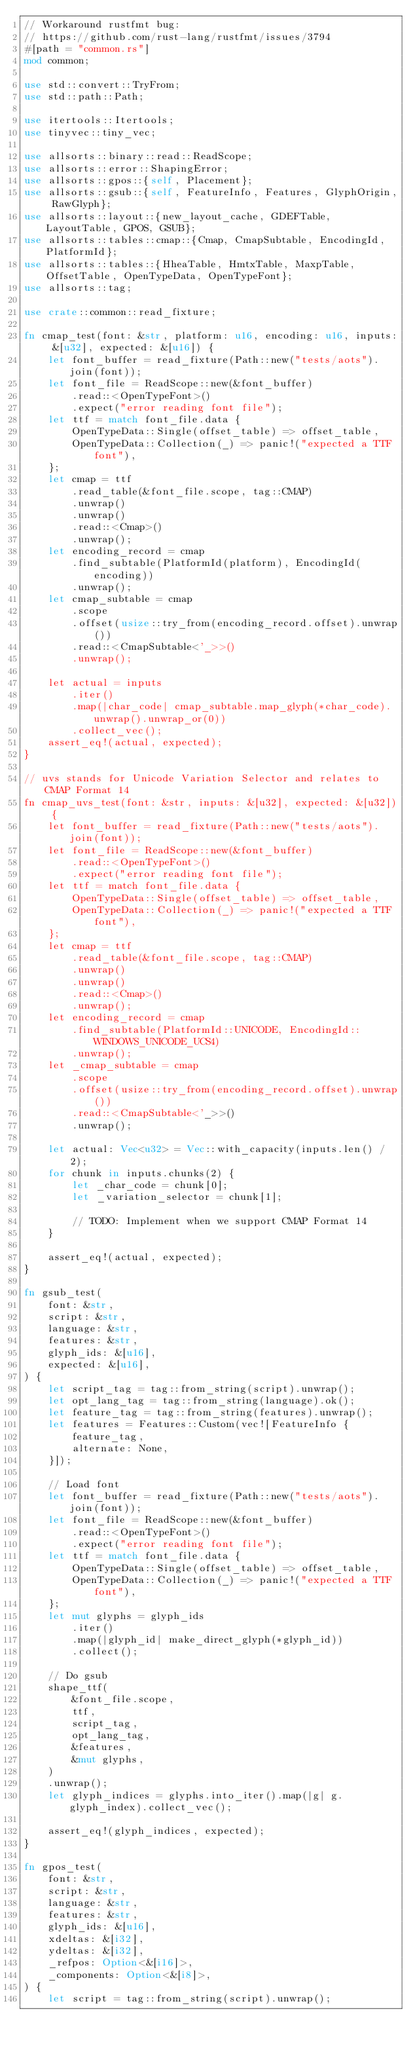<code> <loc_0><loc_0><loc_500><loc_500><_Rust_>// Workaround rustfmt bug:
// https://github.com/rust-lang/rustfmt/issues/3794
#[path = "common.rs"]
mod common;

use std::convert::TryFrom;
use std::path::Path;

use itertools::Itertools;
use tinyvec::tiny_vec;

use allsorts::binary::read::ReadScope;
use allsorts::error::ShapingError;
use allsorts::gpos::{self, Placement};
use allsorts::gsub::{self, FeatureInfo, Features, GlyphOrigin, RawGlyph};
use allsorts::layout::{new_layout_cache, GDEFTable, LayoutTable, GPOS, GSUB};
use allsorts::tables::cmap::{Cmap, CmapSubtable, EncodingId, PlatformId};
use allsorts::tables::{HheaTable, HmtxTable, MaxpTable, OffsetTable, OpenTypeData, OpenTypeFont};
use allsorts::tag;

use crate::common::read_fixture;

fn cmap_test(font: &str, platform: u16, encoding: u16, inputs: &[u32], expected: &[u16]) {
    let font_buffer = read_fixture(Path::new("tests/aots").join(font));
    let font_file = ReadScope::new(&font_buffer)
        .read::<OpenTypeFont>()
        .expect("error reading font file");
    let ttf = match font_file.data {
        OpenTypeData::Single(offset_table) => offset_table,
        OpenTypeData::Collection(_) => panic!("expected a TTF font"),
    };
    let cmap = ttf
        .read_table(&font_file.scope, tag::CMAP)
        .unwrap()
        .unwrap()
        .read::<Cmap>()
        .unwrap();
    let encoding_record = cmap
        .find_subtable(PlatformId(platform), EncodingId(encoding))
        .unwrap();
    let cmap_subtable = cmap
        .scope
        .offset(usize::try_from(encoding_record.offset).unwrap())
        .read::<CmapSubtable<'_>>()
        .unwrap();

    let actual = inputs
        .iter()
        .map(|char_code| cmap_subtable.map_glyph(*char_code).unwrap().unwrap_or(0))
        .collect_vec();
    assert_eq!(actual, expected);
}

// uvs stands for Unicode Variation Selector and relates to CMAP Format 14
fn cmap_uvs_test(font: &str, inputs: &[u32], expected: &[u32]) {
    let font_buffer = read_fixture(Path::new("tests/aots").join(font));
    let font_file = ReadScope::new(&font_buffer)
        .read::<OpenTypeFont>()
        .expect("error reading font file");
    let ttf = match font_file.data {
        OpenTypeData::Single(offset_table) => offset_table,
        OpenTypeData::Collection(_) => panic!("expected a TTF font"),
    };
    let cmap = ttf
        .read_table(&font_file.scope, tag::CMAP)
        .unwrap()
        .unwrap()
        .read::<Cmap>()
        .unwrap();
    let encoding_record = cmap
        .find_subtable(PlatformId::UNICODE, EncodingId::WINDOWS_UNICODE_UCS4)
        .unwrap();
    let _cmap_subtable = cmap
        .scope
        .offset(usize::try_from(encoding_record.offset).unwrap())
        .read::<CmapSubtable<'_>>()
        .unwrap();

    let actual: Vec<u32> = Vec::with_capacity(inputs.len() / 2);
    for chunk in inputs.chunks(2) {
        let _char_code = chunk[0];
        let _variation_selector = chunk[1];

        // TODO: Implement when we support CMAP Format 14
    }

    assert_eq!(actual, expected);
}

fn gsub_test(
    font: &str,
    script: &str,
    language: &str,
    features: &str,
    glyph_ids: &[u16],
    expected: &[u16],
) {
    let script_tag = tag::from_string(script).unwrap();
    let opt_lang_tag = tag::from_string(language).ok();
    let feature_tag = tag::from_string(features).unwrap();
    let features = Features::Custom(vec![FeatureInfo {
        feature_tag,
        alternate: None,
    }]);

    // Load font
    let font_buffer = read_fixture(Path::new("tests/aots").join(font));
    let font_file = ReadScope::new(&font_buffer)
        .read::<OpenTypeFont>()
        .expect("error reading font file");
    let ttf = match font_file.data {
        OpenTypeData::Single(offset_table) => offset_table,
        OpenTypeData::Collection(_) => panic!("expected a TTF font"),
    };
    let mut glyphs = glyph_ids
        .iter()
        .map(|glyph_id| make_direct_glyph(*glyph_id))
        .collect();

    // Do gsub
    shape_ttf(
        &font_file.scope,
        ttf,
        script_tag,
        opt_lang_tag,
        &features,
        &mut glyphs,
    )
    .unwrap();
    let glyph_indices = glyphs.into_iter().map(|g| g.glyph_index).collect_vec();

    assert_eq!(glyph_indices, expected);
}

fn gpos_test(
    font: &str,
    script: &str,
    language: &str,
    features: &str,
    glyph_ids: &[u16],
    xdeltas: &[i32],
    ydeltas: &[i32],
    _refpos: Option<&[i16]>,
    _components: Option<&[i8]>,
) {
    let script = tag::from_string(script).unwrap();</code> 